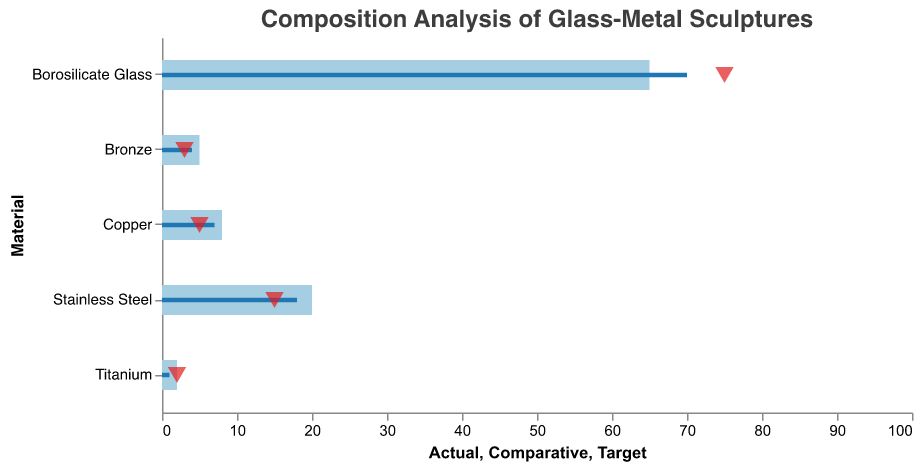What's the title of the chart? The title of the chart is displayed at the top, written in a bold and larger font compared to other text.
Answer: Composition Analysis of Glass-Metal Sculptures How much Borosilicate Glass is actually used in the sculptures? The actual percentage for Borosilicate Glass is shown as the largest bar, and the value is indicated in the tooltip when you hover over it.
Answer: 65% Which material has the smallest target value? Look at the triangle markers which denote target values for each material. Identify the smallest of these figures.
Answer: Bronze What is the difference between the actual and comparative values for Stainless Steel? Subtract the comparative value from the actual value for Stainless Steel: 20 (Actual) - 18 (Comparative).
Answer: 2 How does the actual percentage of Copper compare to its target? Check the bar and the triangle marker for Copper to see the actual and target values: 8 (Actual) vs. 5 (Target).
Answer: Actual is 3% higher than the target Which material has achieved its target exactly? Look for a triangle marker exactly at the end of a bar. In this case, Titanium has both actual and target values at 2%.
Answer: Titanium What is the average target value across all materials? Sum all target values: 75 + 15 + 5 + 3 + 2 = 100, then divide by the number of materials (5).
Answer: 20% Which material has the largest difference between its actual and target values? Calculate the difference (absolute value) between actual and target for each material and compare: Borosilicate Glass (10), Stainless Steel (5), Copper (3), Bronze (2), Titanium (0). Borosilicate Glass has the largest difference.
Answer: Borosilicate Glass How many materials have an actual usage percentage higher than their target? Compare the actual and target values for each material: Borosilicate Glass, Stainless Steel, Copper, Bronze (4 materials).
Answer: 4 materials What's the comparative percentage value for Bronze? Visualize the middle, darker colored bar for Bronze to see its comparative value.
Answer: 4 